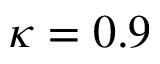Convert formula to latex. <formula><loc_0><loc_0><loc_500><loc_500>\kappa = 0 . 9</formula> 